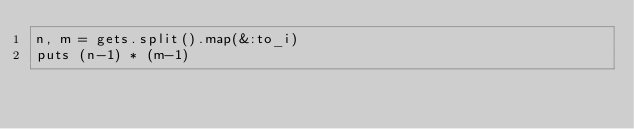<code> <loc_0><loc_0><loc_500><loc_500><_Ruby_>n, m = gets.split().map(&:to_i)
puts (n-1) * (m-1)</code> 